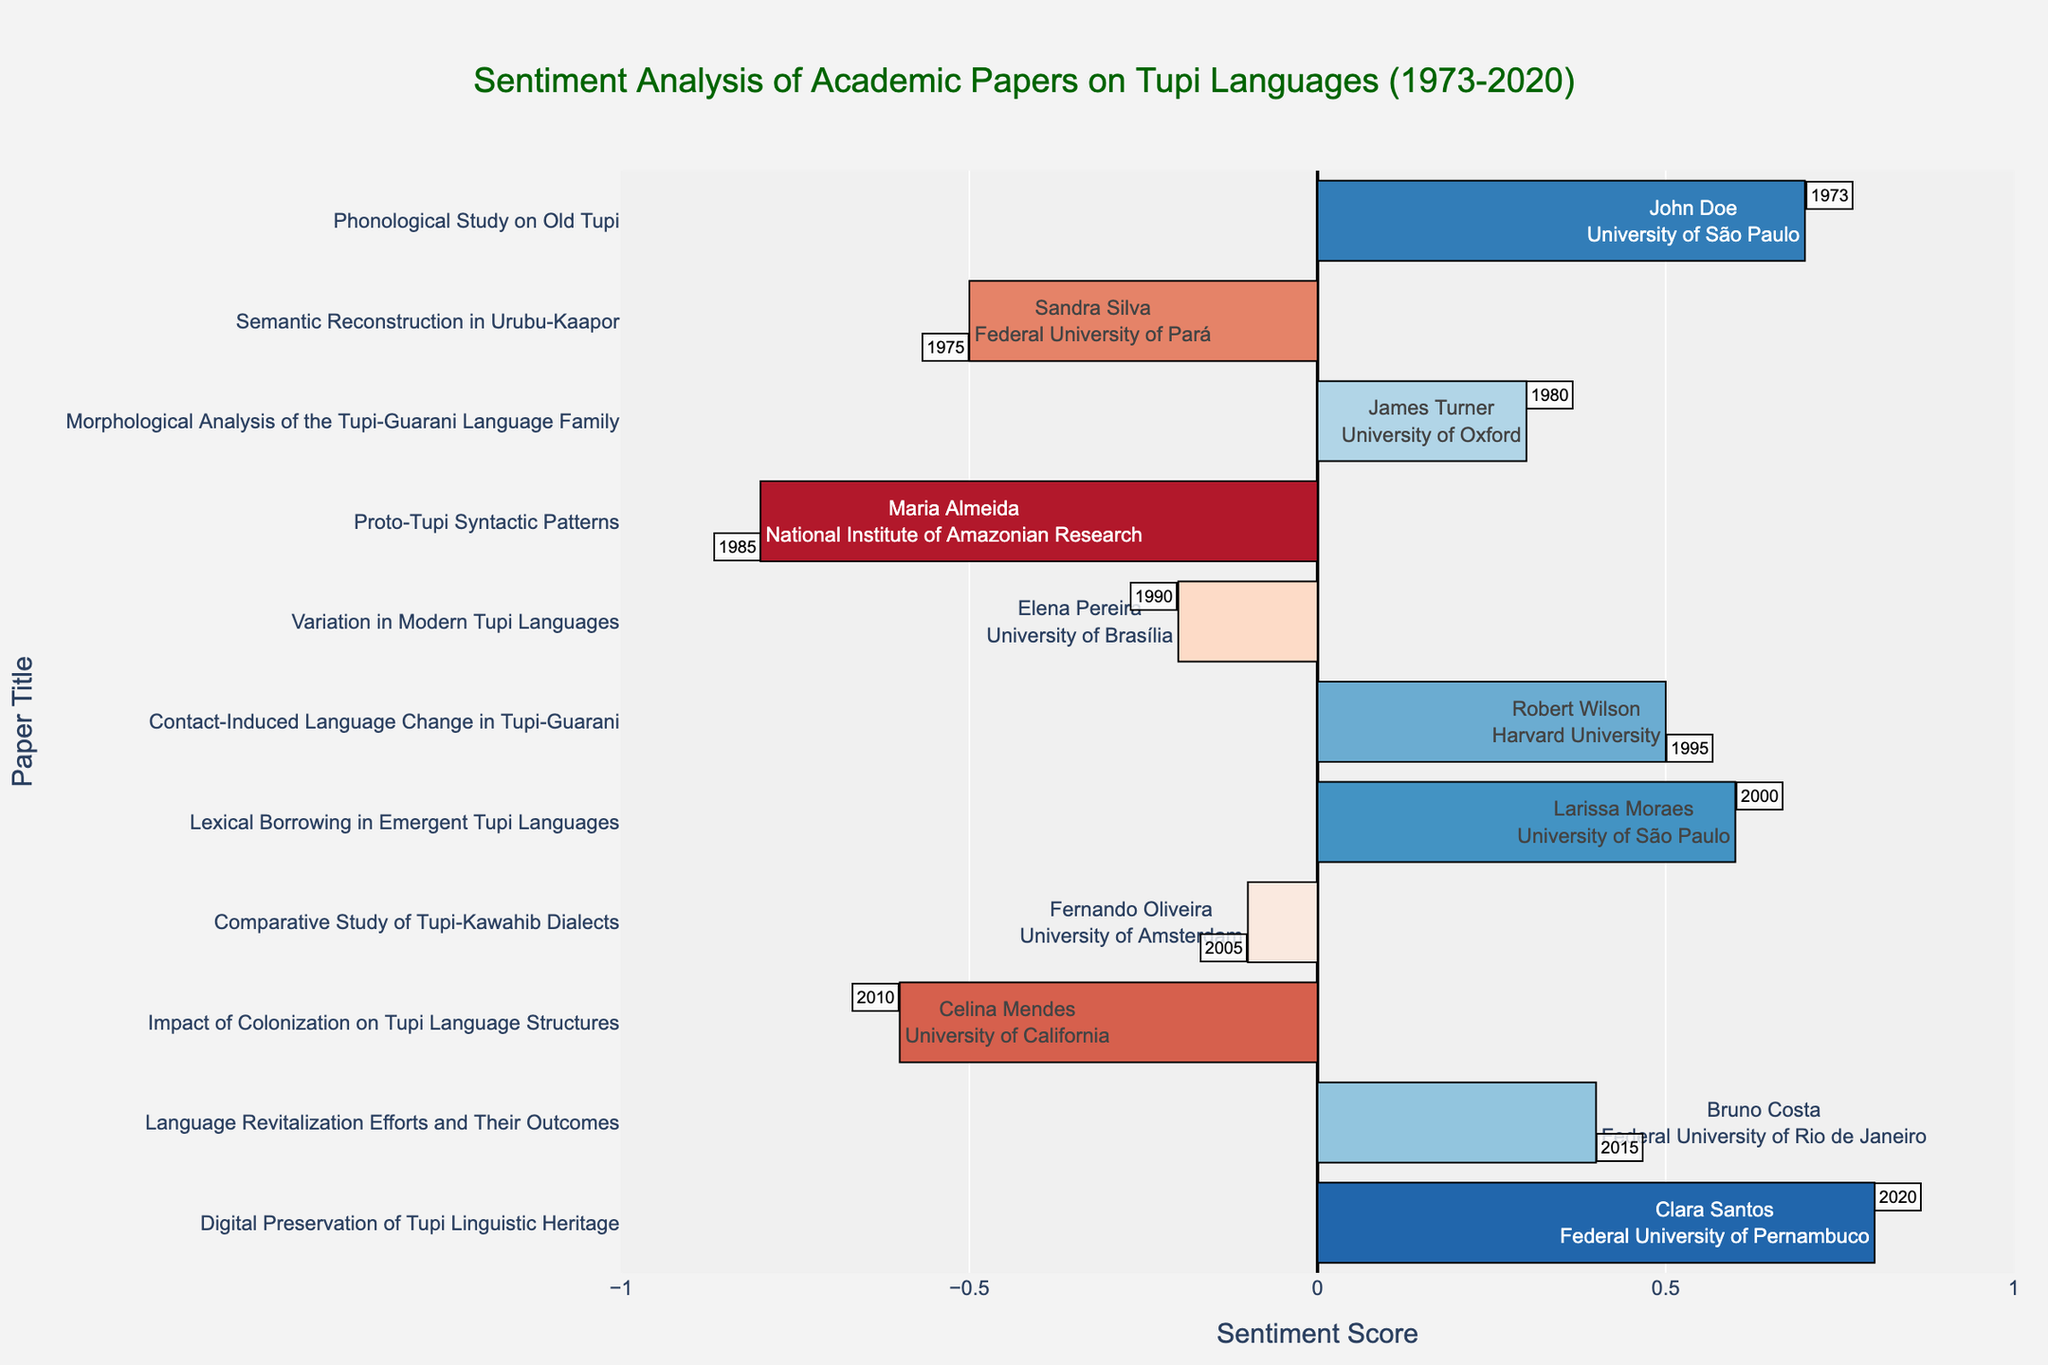What is the sentiment score of the paper titled "Morphological Analysis of the Tupi-Guarani Language Family"? Locate the bar corresponding to the paper titled "Morphological Analysis of the Tupi-Guarani Language Family" and check its sentiment score
Answer: 0.3 Which paper has the highest positive sentiment score? Look for the bar with the most extensive positive length and label it
Answer: "Digital Preservation of Tupi Linguistic Heritage" How many papers have a negative sentiment score, and what is their average sentiment score? Count the bars extending to the left (negative side) and then calculate their average sentiment score; there are 4 papers with scores: -0.5, -0.8, -0.2, and -0.6. Sum them up (-0.5 + -0.8 + -0.2 + -0.6 = -2.1) and divide by 4 (-2.1 / 4)
Answer: 4 papers, -0.525 average Which year saw the most positive sentiment score paper and by which researcher? Identify the bar with the highest positive length, check the year, and the researcher associated with it
Answer: 2020, Clara Santos Compare the sentiment score of the paper titled "Proto-Tupi Syntactic Patterns" with "Variation in Modern Tupi Languages." Which one is higher? Find the sentiment scores of both papers: "Proto-Tupi Syntactic Patterns" is -0.8, and "Variation in Modern Tupi Languages" is -0.2. Compare these values
Answer: Variation in Modern Tupi Languages is higher What is the sentiment score range (difference between the highest and lowest) for the papers? Identify the highest sentiment score (0.8) and the lowest sentiment score (-0.8), then calculate the difference (0.8 - (-0.8) = 1.6)
Answer: 1.6 Which paper, written by a researcher from the University of São Paulo, has the highest sentiment score? Look for bars with "University of São Paulo" in the hover text and identify the one with the highest sentiment score
Answer: "Digital Preservation of Tupi Linguistic Heritage" What is the sentiment score of the paper titled "Comparative Study of Tupi-Kawahib Dialects" and what does its color (shade) indicate about the sentiment? Locate the bar titled "Comparative Study of Tupi-Kawahib Dialects," find its sentiment score (-0.1), and note that its color would be a light shade indicating a weak negative sentiment
Answer: Sentiment score is -0.1 and indicates a weak negative sentiment 